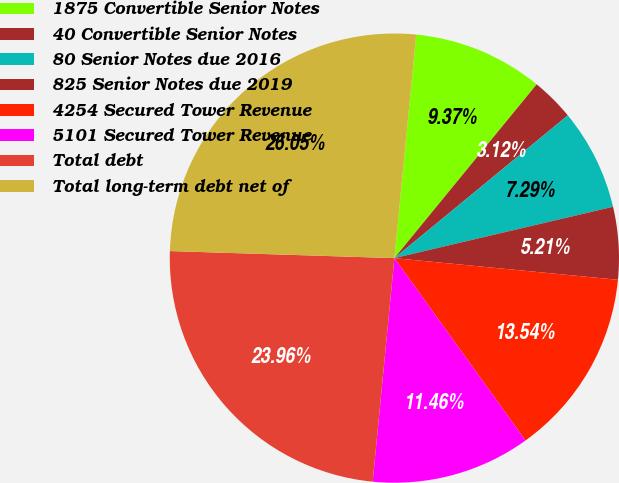Convert chart to OTSL. <chart><loc_0><loc_0><loc_500><loc_500><pie_chart><fcel>1875 Convertible Senior Notes<fcel>40 Convertible Senior Notes<fcel>80 Senior Notes due 2016<fcel>825 Senior Notes due 2019<fcel>4254 Secured Tower Revenue<fcel>5101 Secured Tower Revenue<fcel>Total debt<fcel>Total long-term debt net of<nl><fcel>9.37%<fcel>3.12%<fcel>7.29%<fcel>5.21%<fcel>13.54%<fcel>11.46%<fcel>23.96%<fcel>26.05%<nl></chart> 